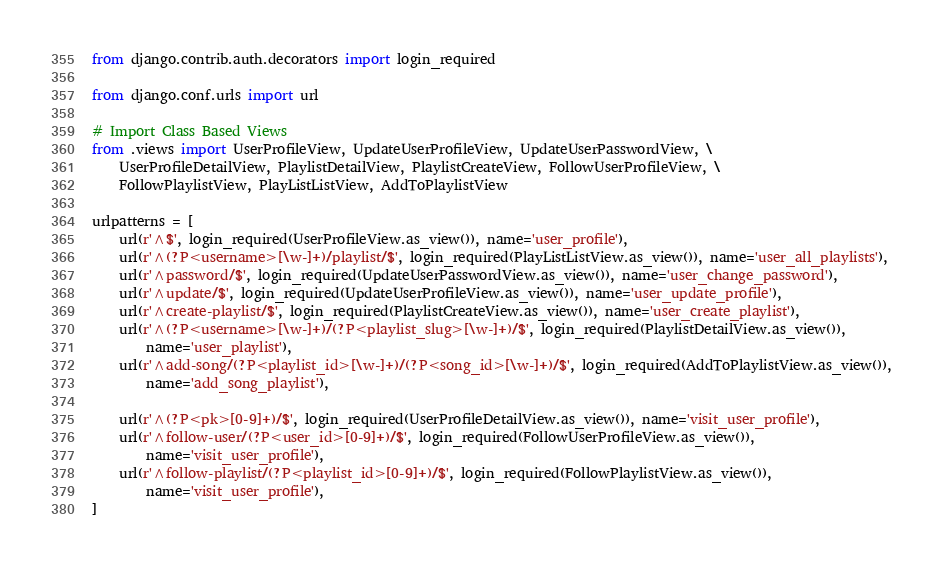Convert code to text. <code><loc_0><loc_0><loc_500><loc_500><_Python_>from django.contrib.auth.decorators import login_required

from django.conf.urls import url

# Import Class Based Views
from .views import UserProfileView, UpdateUserProfileView, UpdateUserPasswordView, \
    UserProfileDetailView, PlaylistDetailView, PlaylistCreateView, FollowUserProfileView, \
    FollowPlaylistView, PlayListListView, AddToPlaylistView

urlpatterns = [
    url(r'^$', login_required(UserProfileView.as_view()), name='user_profile'),
    url(r'^(?P<username>[\w-]+)/playlist/$', login_required(PlayListListView.as_view()), name='user_all_playlists'),
    url(r'^password/$', login_required(UpdateUserPasswordView.as_view()), name='user_change_password'),
    url(r'^update/$', login_required(UpdateUserProfileView.as_view()), name='user_update_profile'),
    url(r'^create-playlist/$', login_required(PlaylistCreateView.as_view()), name='user_create_playlist'),
    url(r'^(?P<username>[\w-]+)/(?P<playlist_slug>[\w-]+)/$', login_required(PlaylistDetailView.as_view()),
        name='user_playlist'),
    url(r'^add-song/(?P<playlist_id>[\w-]+)/(?P<song_id>[\w-]+)/$', login_required(AddToPlaylistView.as_view()),
        name='add_song_playlist'),

    url(r'^(?P<pk>[0-9]+)/$', login_required(UserProfileDetailView.as_view()), name='visit_user_profile'),
    url(r'^follow-user/(?P<user_id>[0-9]+)/$', login_required(FollowUserProfileView.as_view()),
        name='visit_user_profile'),
    url(r'^follow-playlist/(?P<playlist_id>[0-9]+)/$', login_required(FollowPlaylistView.as_view()),
        name='visit_user_profile'),
]
</code> 